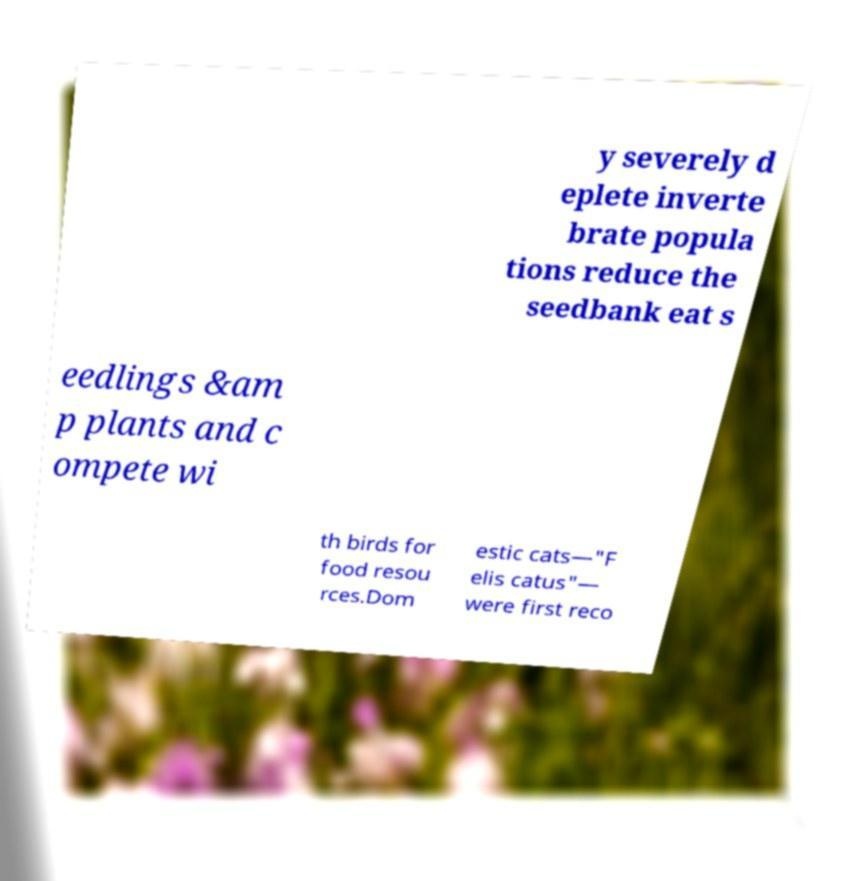I need the written content from this picture converted into text. Can you do that? y severely d eplete inverte brate popula tions reduce the seedbank eat s eedlings &am p plants and c ompete wi th birds for food resou rces.Dom estic cats—"F elis catus"— were first reco 